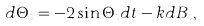Convert formula to latex. <formula><loc_0><loc_0><loc_500><loc_500>d \Theta _ { t } = - 2 \sin \Theta _ { t } d t - k d B _ { t } ,</formula> 